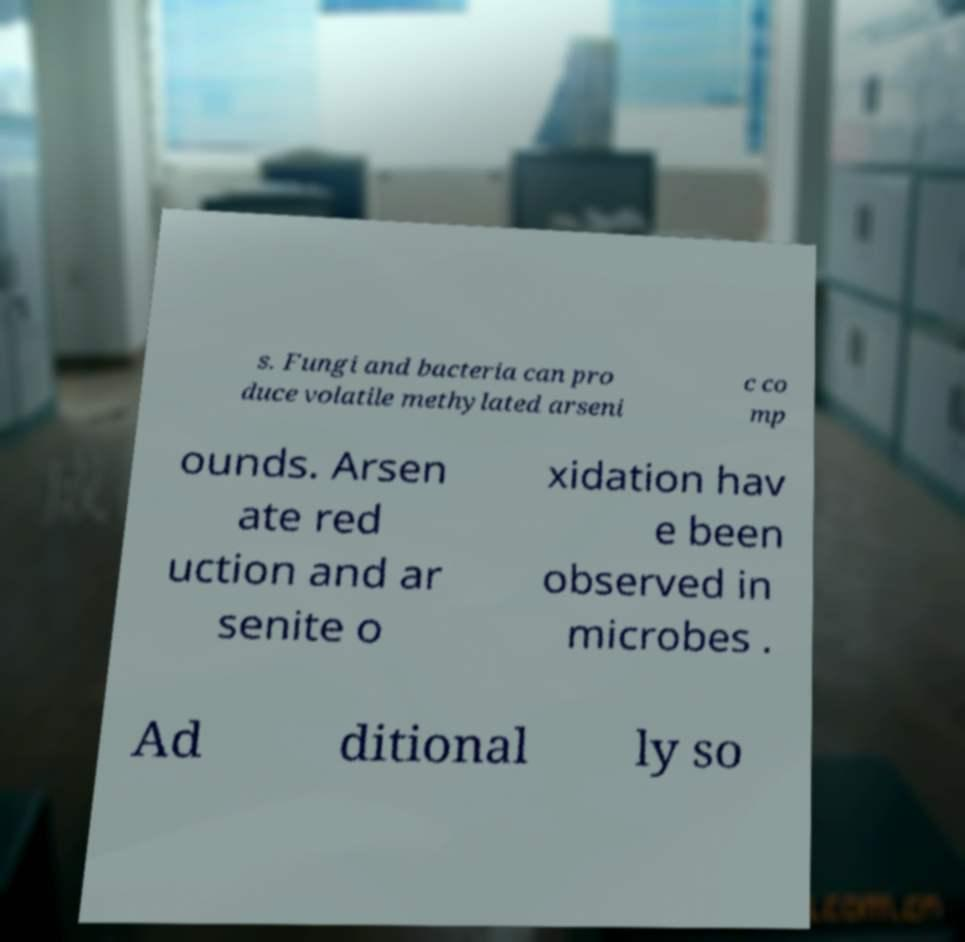For documentation purposes, I need the text within this image transcribed. Could you provide that? s. Fungi and bacteria can pro duce volatile methylated arseni c co mp ounds. Arsen ate red uction and ar senite o xidation hav e been observed in microbes . Ad ditional ly so 